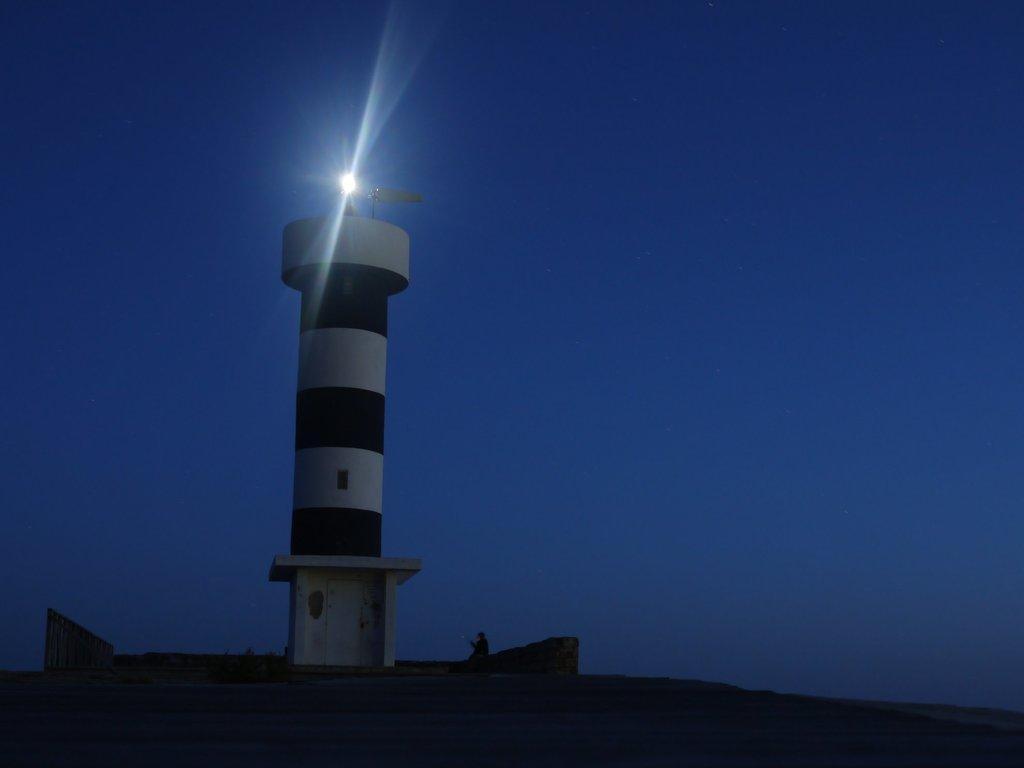Can you describe this image briefly? In the image there is a light house in the middle with a light above it and it seems to be a person sitting in front of it on the rock and above its sky. 